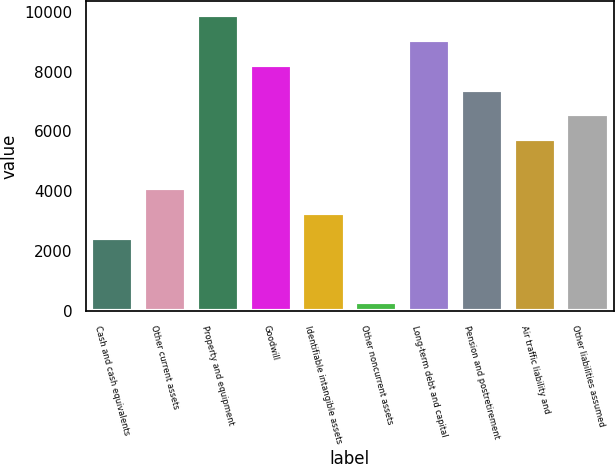<chart> <loc_0><loc_0><loc_500><loc_500><bar_chart><fcel>Cash and cash equivalents<fcel>Other current assets<fcel>Property and equipment<fcel>Goodwill<fcel>Identifiable intangible assets<fcel>Other noncurrent assets<fcel>Long-term debt and capital<fcel>Pension and postretirement<fcel>Air traffic liability and<fcel>Other liabilities assumed<nl><fcel>2441<fcel>4093<fcel>9875<fcel>8223<fcel>3267<fcel>292<fcel>9049<fcel>7397<fcel>5745<fcel>6571<nl></chart> 